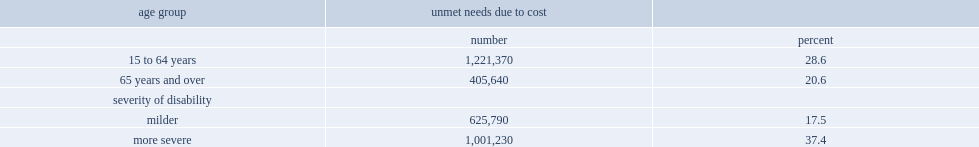What percent of the 4.3 million persons with disabilities aged 15 to 64 years had an unmet need for an aid, device, and/or prescription medication due to cost, compared to two in ten 21% of the nearly 2 million seniors with disabilities? 28.6. Which severity of disability was more likely to have unmet needs due to cost? those with more severe disabilities or those with milder disabilities? More severe. What percent of persons with severe disabilities aged 15 years and over who were living below canada's official poverty line reported an unmet need due to cost for an aid, device, and/or prescription medication? 37.4. 